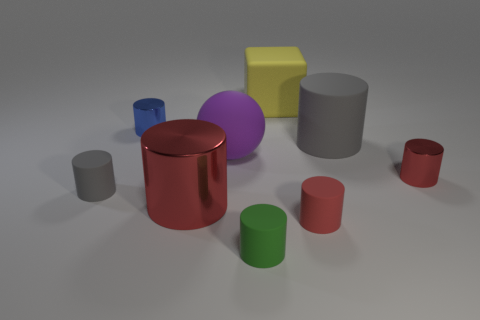Subtract all red blocks. How many red cylinders are left? 3 Subtract 5 cylinders. How many cylinders are left? 2 Subtract all green cylinders. How many cylinders are left? 6 Subtract all small red cylinders. How many cylinders are left? 5 Subtract all brown cylinders. Subtract all brown cubes. How many cylinders are left? 7 Subtract all cubes. How many objects are left? 8 Add 5 tiny gray shiny cubes. How many tiny gray shiny cubes exist? 5 Subtract 0 yellow cylinders. How many objects are left? 9 Subtract all big green matte spheres. Subtract all gray rubber cylinders. How many objects are left? 7 Add 6 yellow rubber blocks. How many yellow rubber blocks are left? 7 